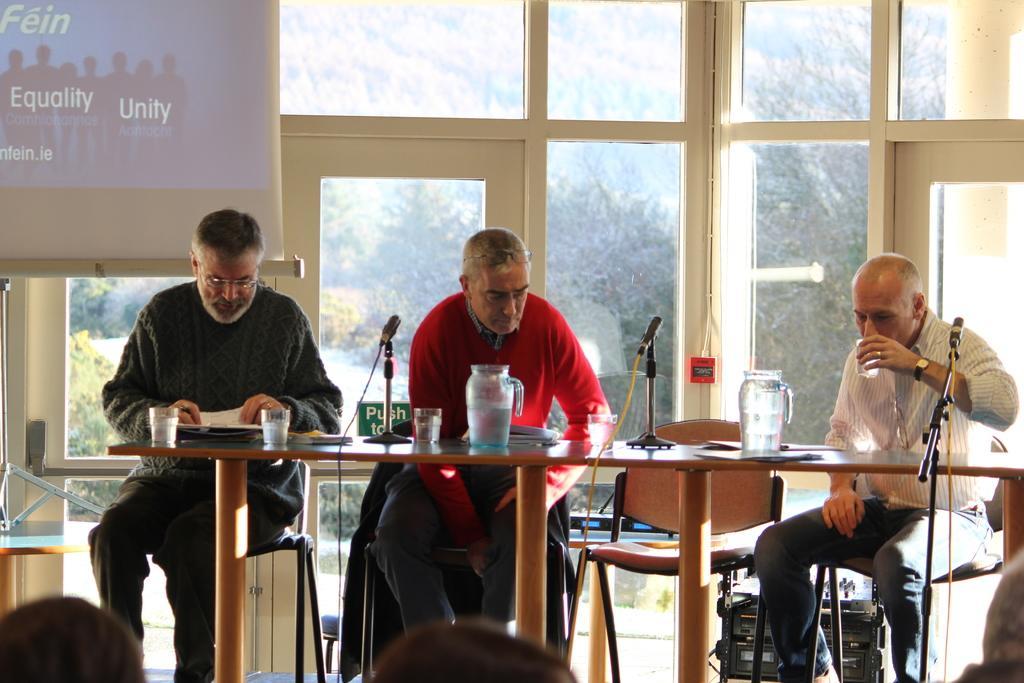Please provide a concise description of this image. This picture shows three men seated on the chairs and we see e Jars and glasses and microphones on the table can we see a man drinking water with help of a glass and we see a projector screen from the window we see trees around 